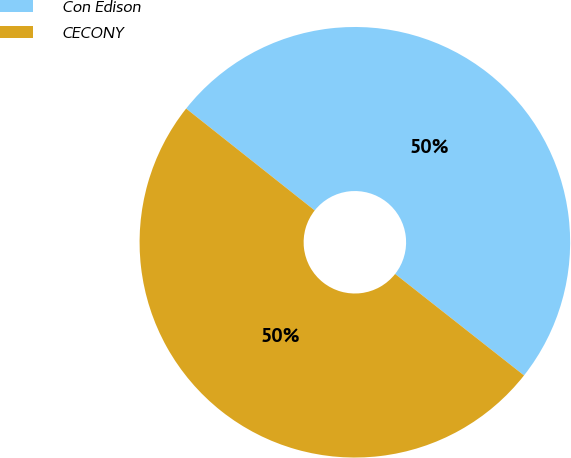Convert chart to OTSL. <chart><loc_0><loc_0><loc_500><loc_500><pie_chart><fcel>Con Edison<fcel>CECONY<nl><fcel>49.95%<fcel>50.05%<nl></chart> 